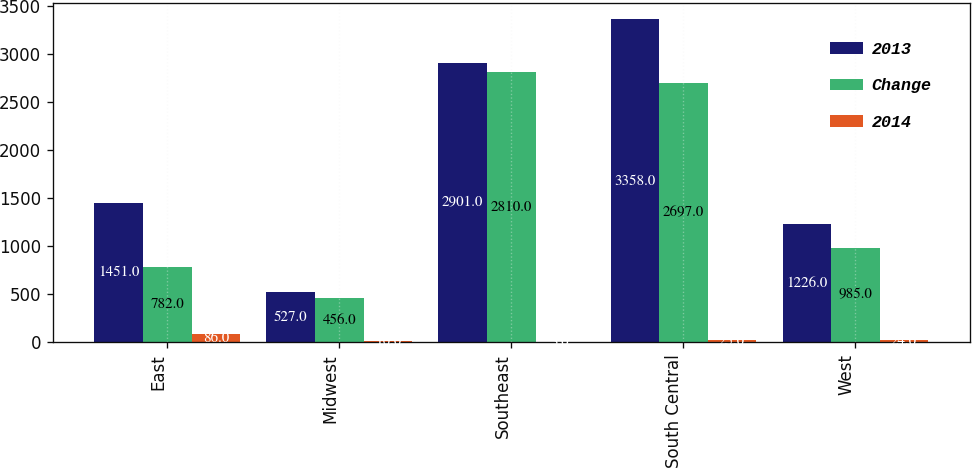Convert chart to OTSL. <chart><loc_0><loc_0><loc_500><loc_500><stacked_bar_chart><ecel><fcel>East<fcel>Midwest<fcel>Southeast<fcel>South Central<fcel>West<nl><fcel>2013<fcel>1451<fcel>527<fcel>2901<fcel>3358<fcel>1226<nl><fcel>Change<fcel>782<fcel>456<fcel>2810<fcel>2697<fcel>985<nl><fcel>2014<fcel>86<fcel>16<fcel>3<fcel>25<fcel>24<nl></chart> 